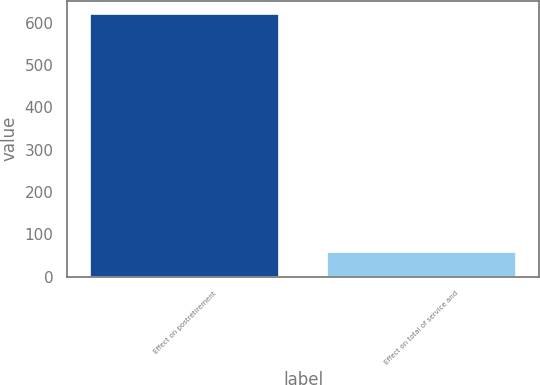Convert chart to OTSL. <chart><loc_0><loc_0><loc_500><loc_500><bar_chart><fcel>Effect on postretirement<fcel>Effect on total of service and<nl><fcel>621<fcel>59<nl></chart> 